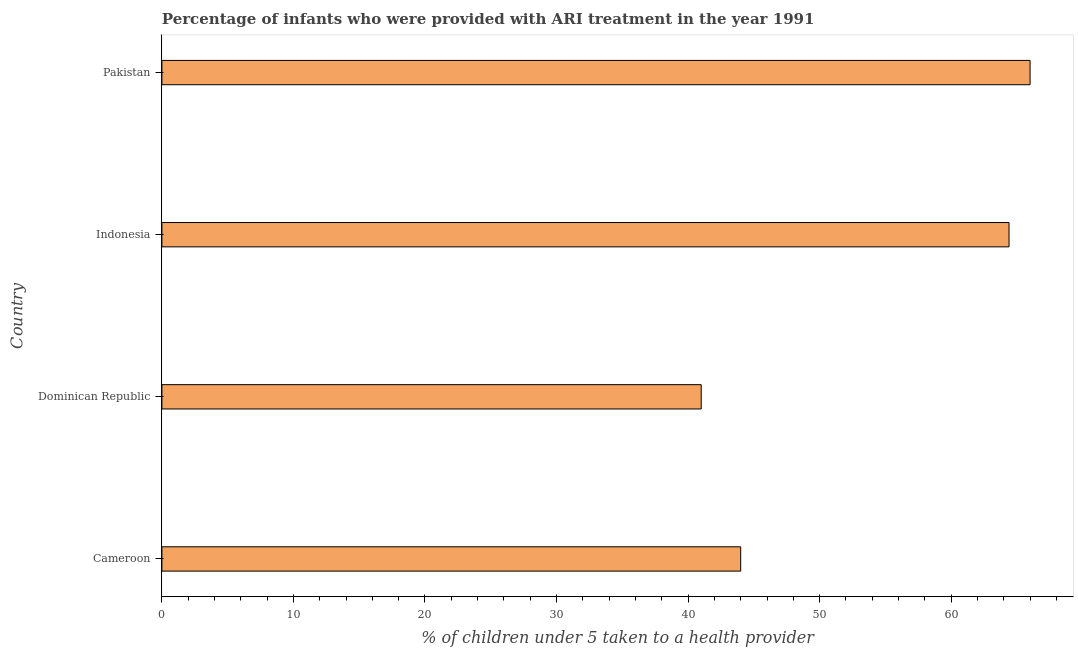Does the graph contain any zero values?
Give a very brief answer. No. Does the graph contain grids?
Your answer should be very brief. No. What is the title of the graph?
Your answer should be very brief. Percentage of infants who were provided with ARI treatment in the year 1991. What is the label or title of the X-axis?
Make the answer very short. % of children under 5 taken to a health provider. What is the label or title of the Y-axis?
Keep it short and to the point. Country. What is the percentage of children who were provided with ari treatment in Pakistan?
Give a very brief answer. 66. Across all countries, what is the maximum percentage of children who were provided with ari treatment?
Offer a terse response. 66. In which country was the percentage of children who were provided with ari treatment maximum?
Offer a very short reply. Pakistan. In which country was the percentage of children who were provided with ari treatment minimum?
Offer a very short reply. Dominican Republic. What is the sum of the percentage of children who were provided with ari treatment?
Give a very brief answer. 215.4. What is the average percentage of children who were provided with ari treatment per country?
Give a very brief answer. 53.85. What is the median percentage of children who were provided with ari treatment?
Give a very brief answer. 54.2. What is the ratio of the percentage of children who were provided with ari treatment in Cameroon to that in Pakistan?
Offer a terse response. 0.67. Is the percentage of children who were provided with ari treatment in Dominican Republic less than that in Indonesia?
Offer a terse response. Yes. What is the difference between the highest and the lowest percentage of children who were provided with ari treatment?
Provide a short and direct response. 25. What is the % of children under 5 taken to a health provider of Indonesia?
Offer a terse response. 64.4. What is the difference between the % of children under 5 taken to a health provider in Cameroon and Indonesia?
Your response must be concise. -20.4. What is the difference between the % of children under 5 taken to a health provider in Cameroon and Pakistan?
Ensure brevity in your answer.  -22. What is the difference between the % of children under 5 taken to a health provider in Dominican Republic and Indonesia?
Keep it short and to the point. -23.4. What is the difference between the % of children under 5 taken to a health provider in Indonesia and Pakistan?
Give a very brief answer. -1.6. What is the ratio of the % of children under 5 taken to a health provider in Cameroon to that in Dominican Republic?
Keep it short and to the point. 1.07. What is the ratio of the % of children under 5 taken to a health provider in Cameroon to that in Indonesia?
Make the answer very short. 0.68. What is the ratio of the % of children under 5 taken to a health provider in Cameroon to that in Pakistan?
Your answer should be compact. 0.67. What is the ratio of the % of children under 5 taken to a health provider in Dominican Republic to that in Indonesia?
Provide a succinct answer. 0.64. What is the ratio of the % of children under 5 taken to a health provider in Dominican Republic to that in Pakistan?
Ensure brevity in your answer.  0.62. 